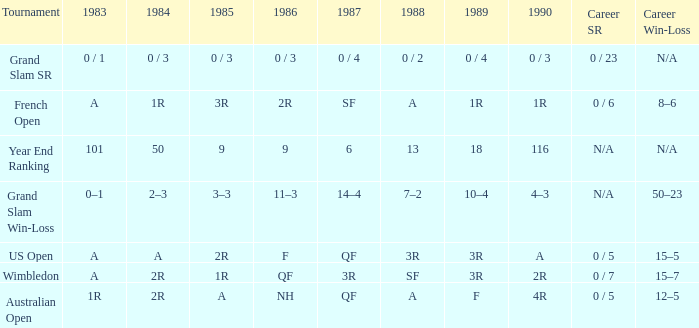With a 1986 of NH and a career SR of 0 / 5 what is the results in 1985? A. Give me the full table as a dictionary. {'header': ['Tournament', '1983', '1984', '1985', '1986', '1987', '1988', '1989', '1990', 'Career SR', 'Career Win-Loss'], 'rows': [['Grand Slam SR', '0 / 1', '0 / 3', '0 / 3', '0 / 3', '0 / 4', '0 / 2', '0 / 4', '0 / 3', '0 / 23', 'N/A'], ['French Open', 'A', '1R', '3R', '2R', 'SF', 'A', '1R', '1R', '0 / 6', '8–6'], ['Year End Ranking', '101', '50', '9', '9', '6', '13', '18', '116', 'N/A', 'N/A'], ['Grand Slam Win-Loss', '0–1', '2–3', '3–3', '11–3', '14–4', '7–2', '10–4', '4–3', 'N/A', '50–23'], ['US Open', 'A', 'A', '2R', 'F', 'QF', '3R', '3R', 'A', '0 / 5', '15–5'], ['Wimbledon', 'A', '2R', '1R', 'QF', '3R', 'SF', '3R', '2R', '0 / 7', '15–7'], ['Australian Open', '1R', '2R', 'A', 'NH', 'QF', 'A', 'F', '4R', '0 / 5', '12–5']]} 